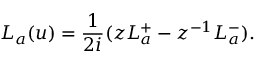Convert formula to latex. <formula><loc_0><loc_0><loc_500><loc_500>L _ { a } ( u ) = { \frac { 1 } { 2 i } } ( z L _ { a } ^ { + } - z ^ { - 1 } L _ { a } ^ { - } ) .</formula> 